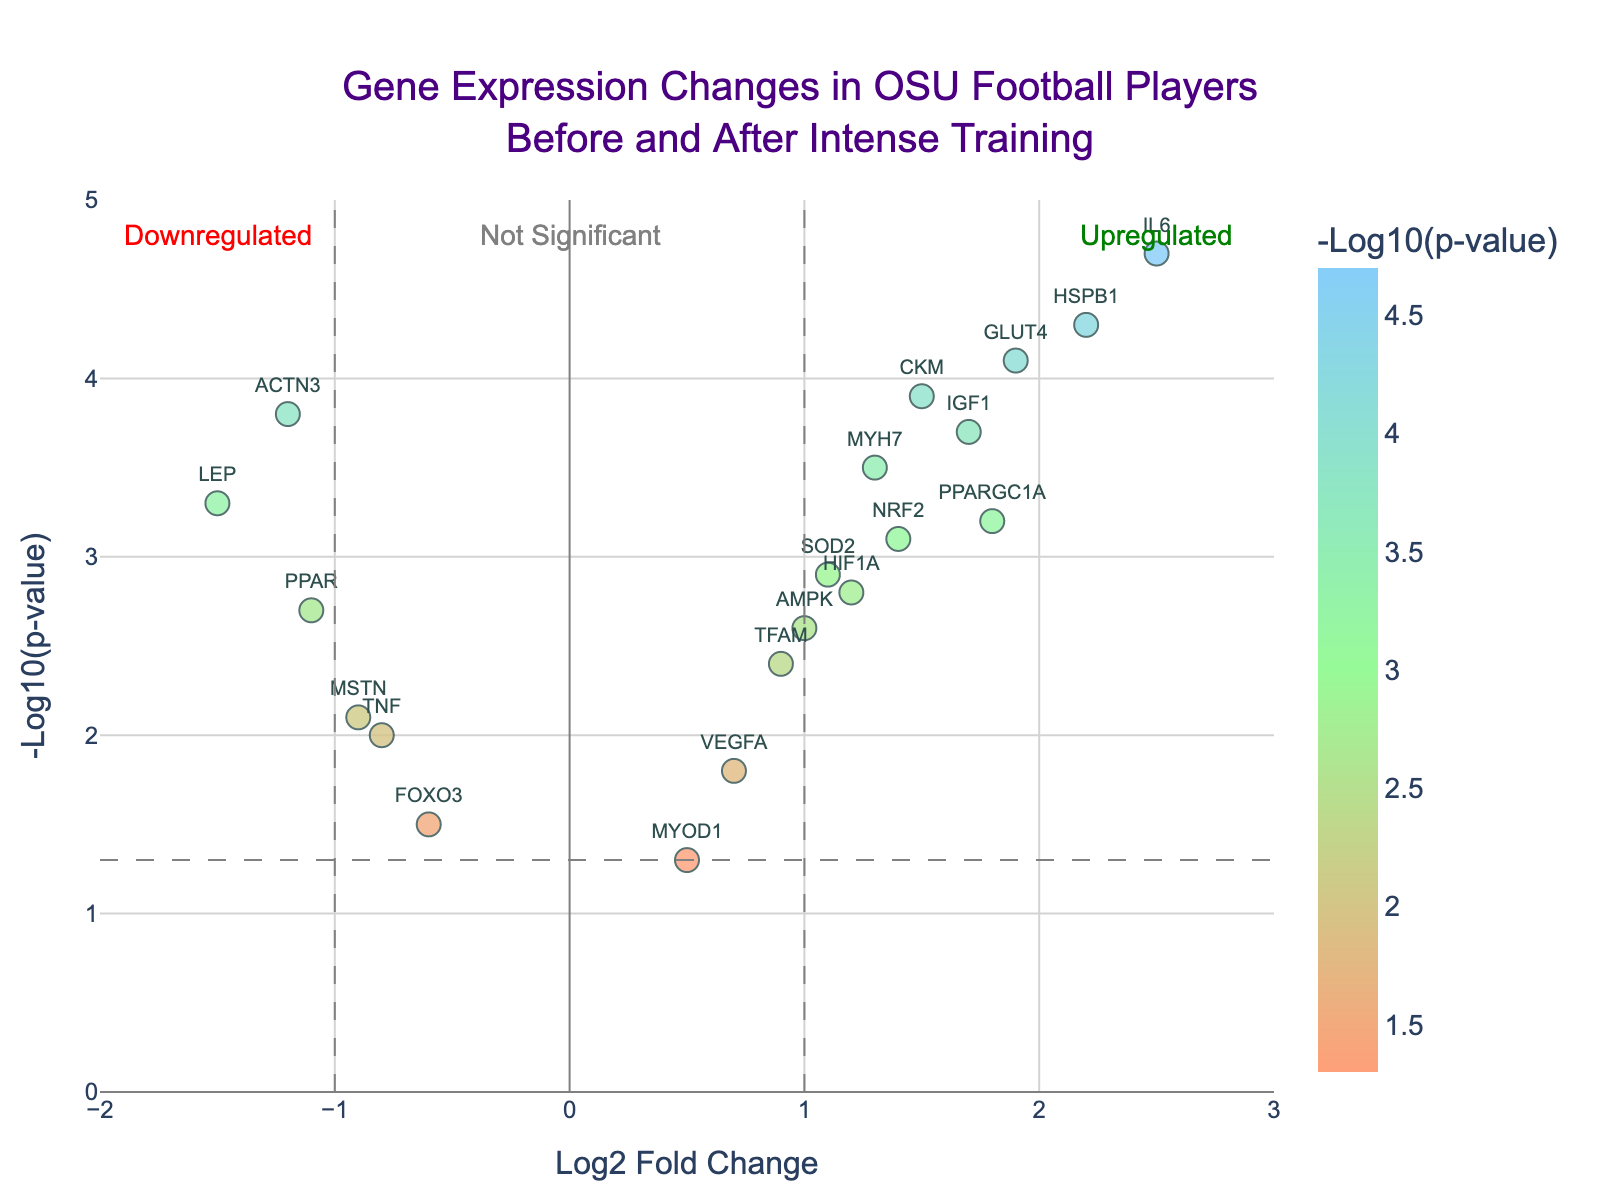What's the title of the plot? The title of the volcano plot is written at the top center. It reads "Gene Expression Changes in OSU Football Players Before and After Intense Training."
Answer: Gene Expression Changes in OSU Football Players Before and After Intense Training How many genes show upregulation based on the plot? Genes that are upregulated have a Log2 Fold Change greater than 1 and a significant -Log10(p-value). By examining the plot, we can see the upregulated genes are those positioned to the right of the vertical line at Log2 Fold Change = 1. These genes include IL6, PPARGC1A, HSPB1, MYH7, IGF1, GLUT4, and NRF2.
Answer: 7 Which gene is the most downregulated? The most downregulated gene will have the most negative Log2 Fold Change. By looking at the leftmost data point with a large negative Log2 Fold Change, we can see that LEP has the smallest Log2 Fold Change of -1.5.
Answer: LEP Which gene has the highest significance level? The highest significance level corresponds to the highest -Log10(p-value). By examining the plot, the gene with the highest -Log10(p-value) is IL6, with a value of 4.7.
Answer: IL6 Are there any genes with a Log2 Fold Change close to zero but still significant? A gene is significant if it has a -Log10(p-value) greater than the threshold line (~1.3). We need to look for points near Log2 Fold Change = 0 but above the threshold. VEGFA seems to fit this description with a Log2 Fold Change of 0.7 and -Log10(p-value) of 1.8.
Answer: VEGFA How many genes have a -Log10(p-value) greater than 3? By counting the data points that have a -Log10(p-value) greater than 3, we observe ACTN3, IL6, HSPB1, MYH7, IGF1, and CKM. This is a total of 6 genes.
Answer: 6 Which genes are considered not significant according to the plot? Not significant genes are below the horizontal significance threshold line. They have a -Log10(p-value) less than roughly 1.3. These genes are FOXO3, TNF, MYOD1, VEGFA, and MSTN.
Answer: FOXO3, TNF, MYOD1, VEGFA, MSTN What do the vertical dashed lines represent? The vertical dashed lines are drawn at Log2 Fold Change values of -1 and 1. These lines represent the thresholds used to define upregulation and downregulation of gene expression. If a gene's Log2 Fold Change is beyond these lines, it is considered significantly upregulated or downregulated.
Answer: Upregulation and downregulation thresholds Compare the expression changes of AKT1 and HSPB1. Which one is more significant and by how much? To compare, find the -Log10(p-value) of each gene. AKT1 has a value of 2.9, while HSPB1 has a value of 4.3. The difference in significance levels is 4.3 - 2.9 = 1.4. Thus, HSPB1 is more significant by 1.4.
Answer: HSPB1, 1.4 